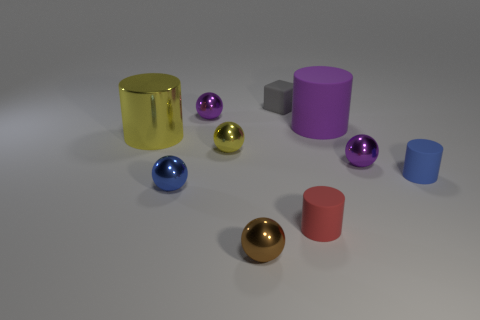There is a tiny yellow metallic sphere; are there any large metallic cylinders in front of it?
Provide a succinct answer. No. Do the blue metal sphere and the purple matte cylinder have the same size?
Ensure brevity in your answer.  No. There is a blue thing on the right side of the small blue shiny object; what is its shape?
Your answer should be very brief. Cylinder. Are there any gray matte things that have the same size as the purple cylinder?
Your response must be concise. No. What is the material of the yellow thing that is the same size as the blue sphere?
Your answer should be compact. Metal. There is a sphere to the right of the small matte block; how big is it?
Your response must be concise. Small. What size is the gray block?
Your answer should be compact. Small. Is the size of the blue rubber thing the same as the matte thing in front of the tiny blue matte cylinder?
Offer a terse response. Yes. The tiny cylinder that is right of the purple ball to the right of the small gray matte cube is what color?
Your answer should be compact. Blue. Are there an equal number of brown metal things in front of the tiny yellow shiny thing and tiny yellow spheres that are in front of the small blue ball?
Your response must be concise. No. 